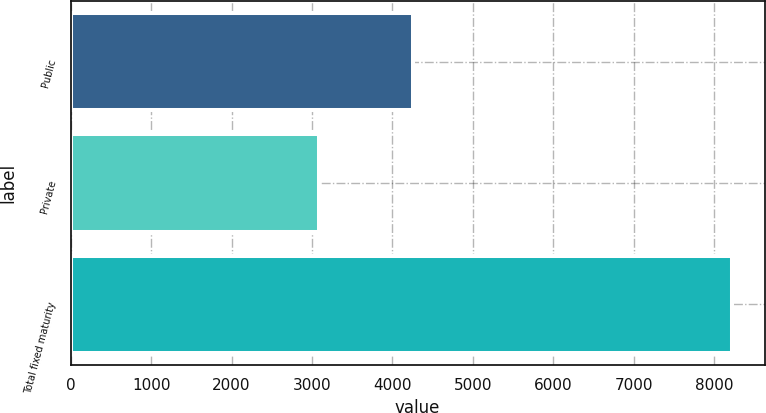Convert chart. <chart><loc_0><loc_0><loc_500><loc_500><bar_chart><fcel>Public<fcel>Private<fcel>Total fixed maturity<nl><fcel>4253.1<fcel>3089.2<fcel>8215.6<nl></chart> 